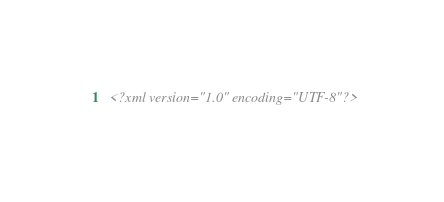Convert code to text. <code><loc_0><loc_0><loc_500><loc_500><_XML_><?xml version="1.0" encoding="UTF-8"?></code> 